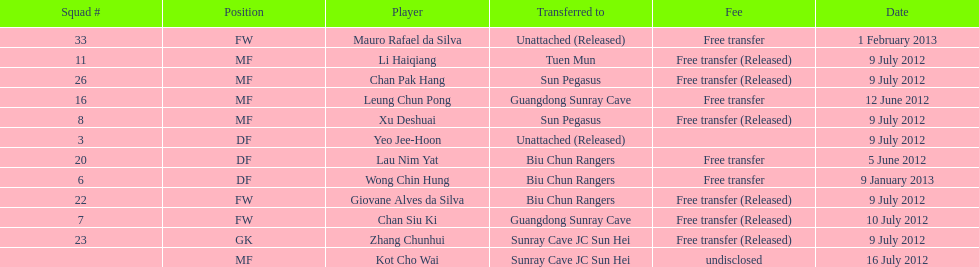Li haiqiang and xu deshuai both played which position? MF. 